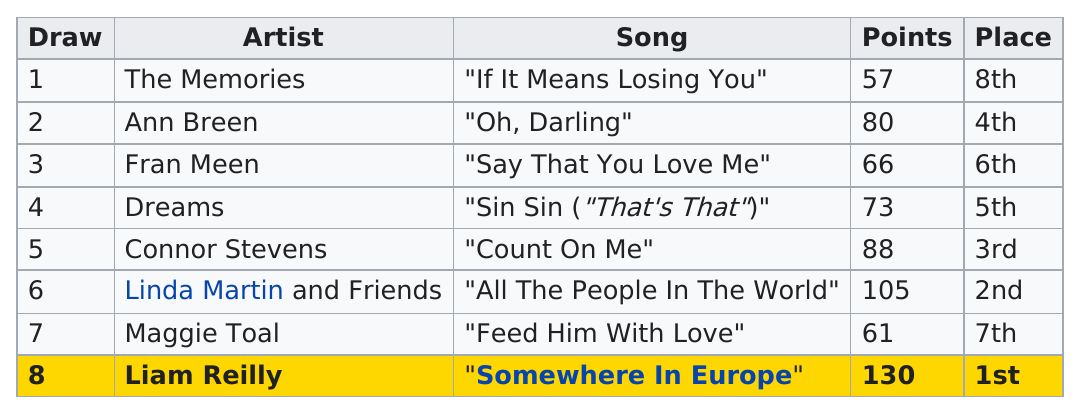Mention a couple of crucial points in this snapshot. Out of the total number of songs that had the word "love" in the title, two of them had the word "love" in the title. I can name one song that did not earn 60 points. That song is 'If It Means Losing You'. After Liam Reilly, which artist had the next highest point total? The answer is Linda Martin and Friends. The song "Somewhere In Europe" received the most points. In the Irish national final for the Eurovision Song Contest in 1990, six artists received less than 90 points. 